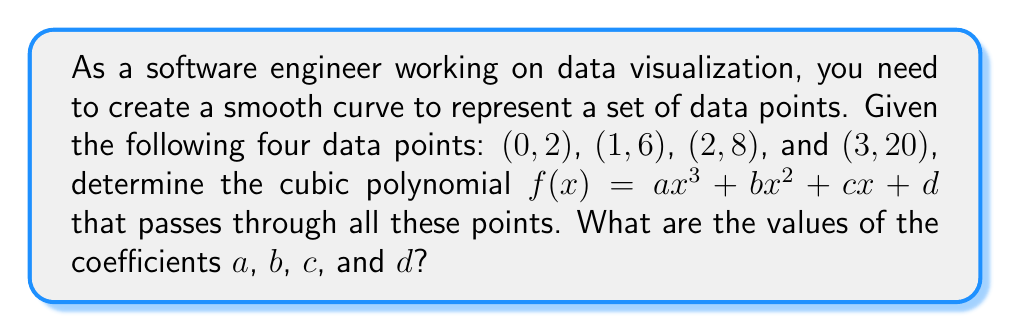Solve this math problem. To find the cubic polynomial that passes through the given points, we need to solve a system of equations. Let's approach this step-by-step:

1) We have the general form of a cubic polynomial: $f(x) = ax^3 + bx^2 + cx + d$

2) We need to create an equation for each given point:

   For (0, 2): $2 = a(0)^3 + b(0)^2 + c(0) + d$
   For (1, 6): $6 = a(1)^3 + b(1)^2 + c(1) + d$
   For (2, 8): $8 = a(2)^3 + b(2)^2 + c(2) + d$
   For (3, 20): $20 = a(3)^3 + b(3)^2 + c(3) + d$

3) Simplify these equations:

   $2 = d$
   $6 = a + b + c + d$
   $8 = 8a + 4b + 2c + d$
   $20 = 27a + 9b + 3c + d$

4) Substitute $d = 2$ into the other equations:

   $4 = a + b + c$
   $6 = 8a + 4b + 2c$
   $18 = 27a + 9b + 3c$

5) Subtract the first equation from the second:

   $2 = 7a + 3b + c$

6) Subtract 3 times the first equation from the third:

   $6 = 24a + 6b$

7) Divide the last equation by 6:

   $1 = 4a + b$

8) Substitute this into the equation from step 5:

   $2 = 7a + 3(1-4a) + c$
   $2 = 7a + 3 - 12a + c$
   $-1 = -5a + c$
   $c = 5a - 1$

9) Substitute this back into the equation from step 4:

   $4 = a + (1-4a) + (5a-1)$
   $4 = a + 1 - 4a + 5a - 1$
   $4 = 2a$
   $a = 2$

10) Now we can find the other coefficients:

    $b = 1 - 4a = 1 - 4(2) = -7$
    $c = 5a - 1 = 5(2) - 1 = 9$
    $d = 2$

Therefore, the cubic polynomial is $f(x) = 2x^3 - 7x^2 + 9x + 2$.
Answer: $f(x) = 2x^3 - 7x^2 + 9x + 2$ 